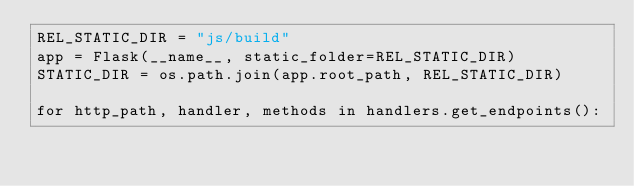Convert code to text. <code><loc_0><loc_0><loc_500><loc_500><_Python_>REL_STATIC_DIR = "js/build"
app = Flask(__name__, static_folder=REL_STATIC_DIR)
STATIC_DIR = os.path.join(app.root_path, REL_STATIC_DIR)

for http_path, handler, methods in handlers.get_endpoints():</code> 